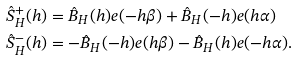<formula> <loc_0><loc_0><loc_500><loc_500>\hat { S } _ { H } ^ { + } ( h ) & = \hat { B } _ { H } ( h ) e ( - h \beta ) + \hat { B } _ { H } ( - h ) e ( h \alpha ) \\ \hat { S } _ { H } ^ { - } ( h ) & = - \hat { B } _ { H } ( - h ) e ( h \beta ) - \hat { B } _ { H } ( h ) e ( - h \alpha ) .</formula> 